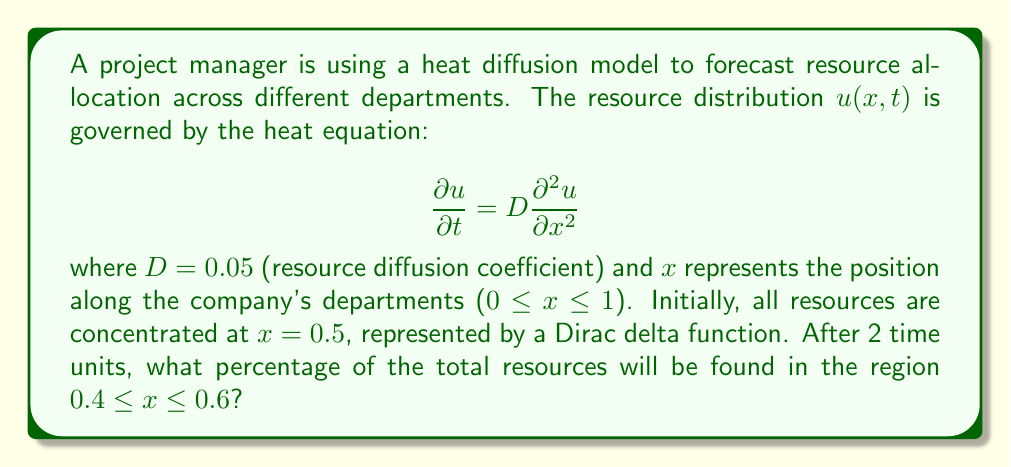Can you answer this question? To solve this problem, we'll follow these steps:

1) The initial condition is a Dirac delta function at x = 0.5. The solution to the heat equation with this initial condition is:

   $$u(x,t) = \frac{1}{\sqrt{4\pi Dt}} e^{-\frac{(x-0.5)^2}{4Dt}}$$

2) We need to find the total resources in the region 0.4 ≤ x ≤ 0.6 at t = 2. This is given by the integral:

   $$\int_{0.4}^{0.6} u(x,2) dx = \int_{0.4}^{0.6} \frac{1}{\sqrt{4\pi D(2)}} e^{-\frac{(x-0.5)^2}{4D(2)}} dx$$

3) Substituting D = 0.05 and simplifying:

   $$\int_{0.4}^{0.6} \frac{1}{\sqrt{4\pi (0.05)(2)}} e^{-\frac{(x-0.5)^2}{4(0.05)(2)}} dx = \int_{0.4}^{0.6} \frac{1}{\sqrt{0.2\pi}} e^{-\frac{(x-0.5)^2}{0.4}} dx$$

4) This integral represents the probability that a normally distributed random variable with mean 0.5 and variance 0.2 falls between 0.4 and 0.6.

5) We can standardize this to the standard normal distribution:

   $$P(0.4 \leq X \leq 0.6) = P(\frac{0.4 - 0.5}{\sqrt{0.2}} \leq Z \leq \frac{0.6 - 0.5}{\sqrt{0.2}}) = P(-0.2236 \leq Z \leq 0.2236)$$

6) Using a standard normal table or calculator:

   $$P(-0.2236 \leq Z \leq 0.2236) = 2 * P(0 \leq Z \leq 0.2236) \approx 2 * 0.0885 = 0.1770$$

7) Convert to percentage: 0.1770 * 100% ≈ 17.70%
Answer: 17.70% 